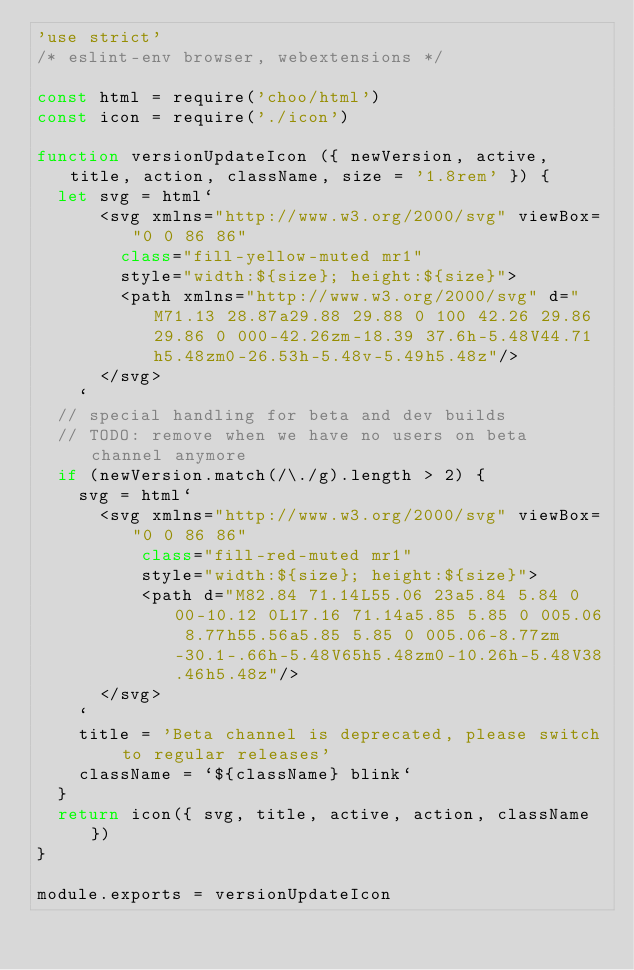Convert code to text. <code><loc_0><loc_0><loc_500><loc_500><_JavaScript_>'use strict'
/* eslint-env browser, webextensions */

const html = require('choo/html')
const icon = require('./icon')

function versionUpdateIcon ({ newVersion, active, title, action, className, size = '1.8rem' }) {
  let svg = html`
      <svg xmlns="http://www.w3.org/2000/svg" viewBox="0 0 86 86"
        class="fill-yellow-muted mr1"
        style="width:${size}; height:${size}">
        <path xmlns="http://www.w3.org/2000/svg" d="M71.13 28.87a29.88 29.88 0 100 42.26 29.86 29.86 0 000-42.26zm-18.39 37.6h-5.48V44.71h5.48zm0-26.53h-5.48v-5.49h5.48z"/>
      </svg>
    `
  // special handling for beta and dev builds
  // TODO: remove when we have no users on beta channel anymore
  if (newVersion.match(/\./g).length > 2) {
    svg = html`
      <svg xmlns="http://www.w3.org/2000/svg" viewBox="0 0 86 86"
          class="fill-red-muted mr1"
          style="width:${size}; height:${size}">
          <path d="M82.84 71.14L55.06 23a5.84 5.84 0 00-10.12 0L17.16 71.14a5.85 5.85 0 005.06 8.77h55.56a5.85 5.85 0 005.06-8.77zm-30.1-.66h-5.48V65h5.48zm0-10.26h-5.48V38.46h5.48z"/>
      </svg>
    `
    title = 'Beta channel is deprecated, please switch to regular releases'
    className = `${className} blink`
  }
  return icon({ svg, title, active, action, className })
}

module.exports = versionUpdateIcon
</code> 